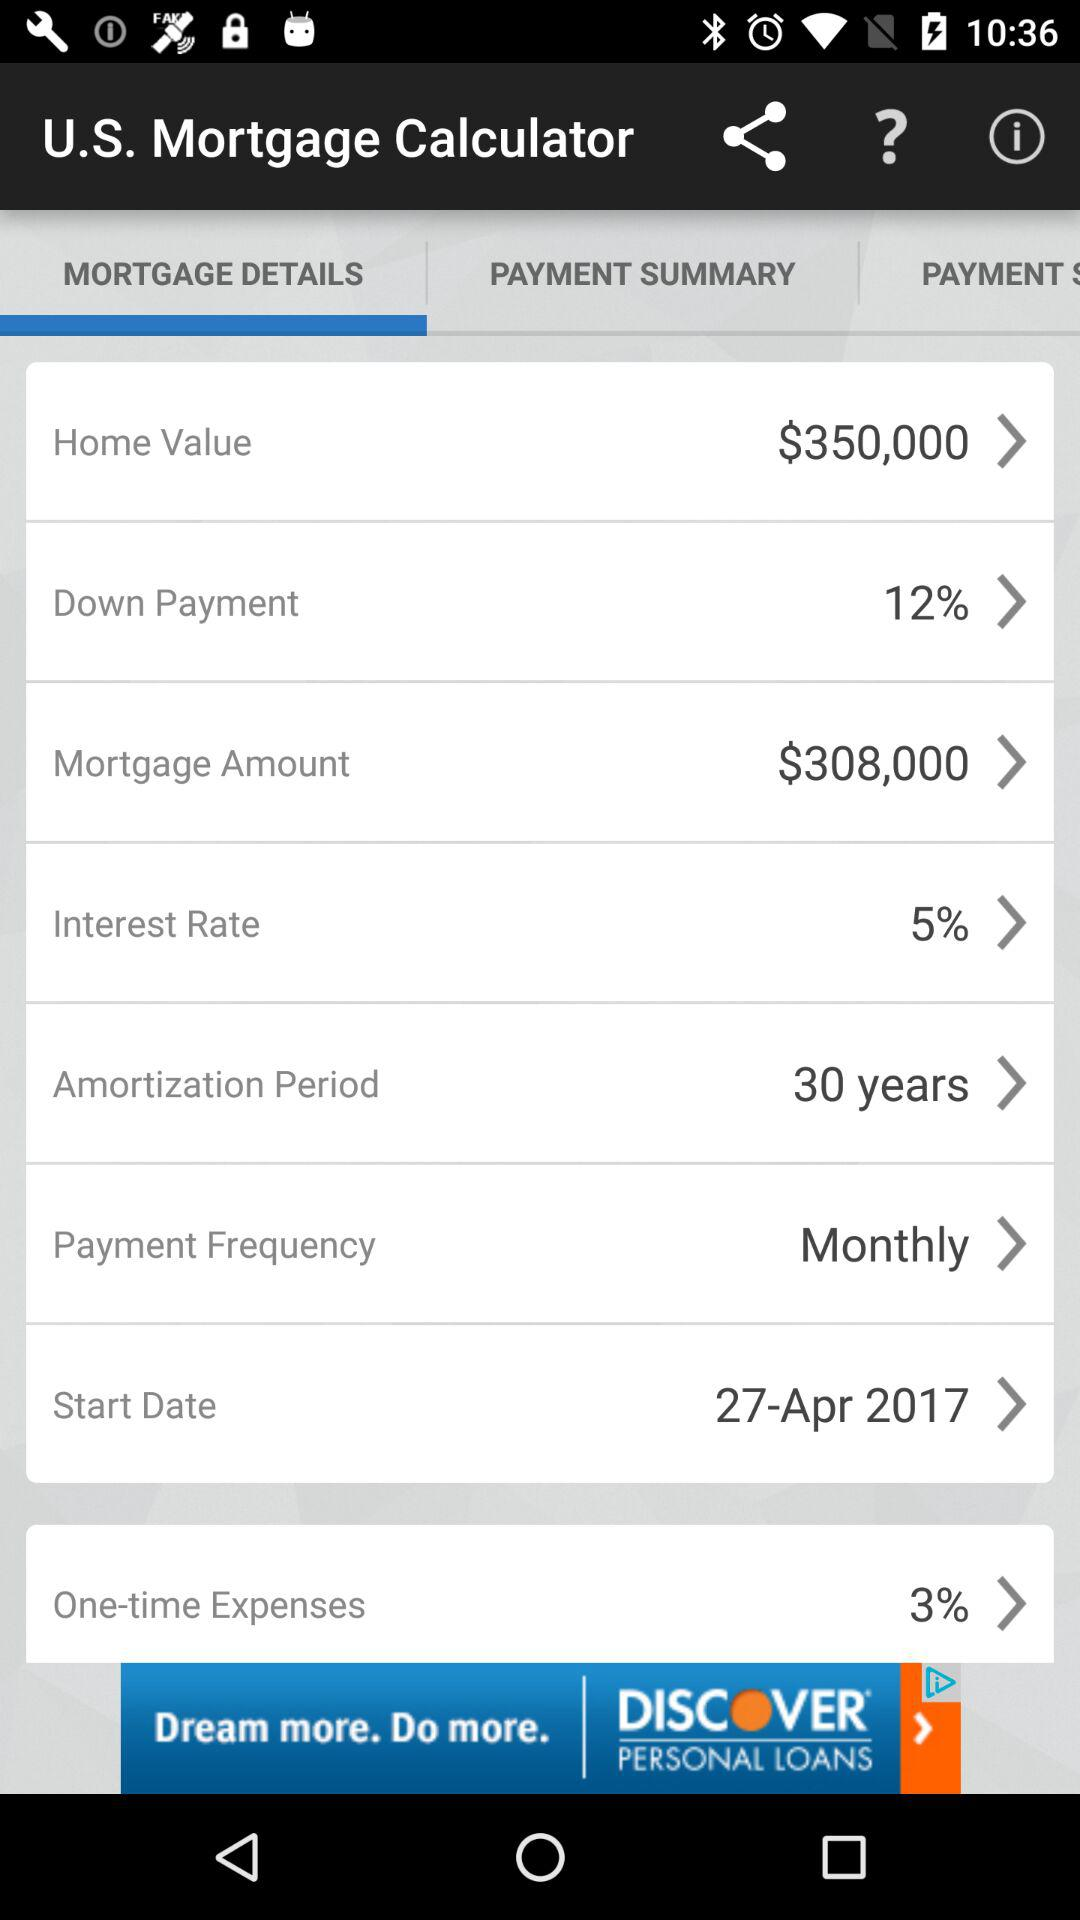What is the interest rate on the mortgage?
Answer the question using a single word or phrase. 5% 